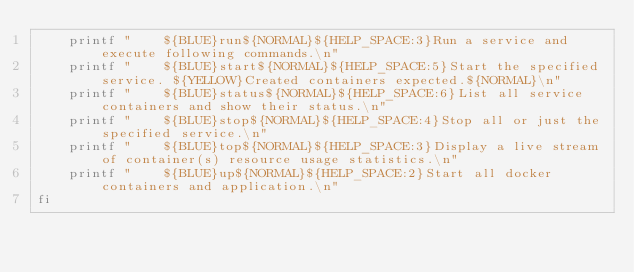Convert code to text. <code><loc_0><loc_0><loc_500><loc_500><_Bash_>    printf "    ${BLUE}run${NORMAL}${HELP_SPACE:3}Run a service and execute following commands.\n"
    printf "    ${BLUE}start${NORMAL}${HELP_SPACE:5}Start the specified service. ${YELLOW}Created containers expected.${NORMAL}\n"
    printf "    ${BLUE}status${NORMAL}${HELP_SPACE:6}List all service containers and show their status.\n"
    printf "    ${BLUE}stop${NORMAL}${HELP_SPACE:4}Stop all or just the specified service.\n"
    printf "    ${BLUE}top${NORMAL}${HELP_SPACE:3}Display a live stream of container(s) resource usage statistics.\n"
    printf "    ${BLUE}up${NORMAL}${HELP_SPACE:2}Start all docker containers and application.\n"
fi
</code> 